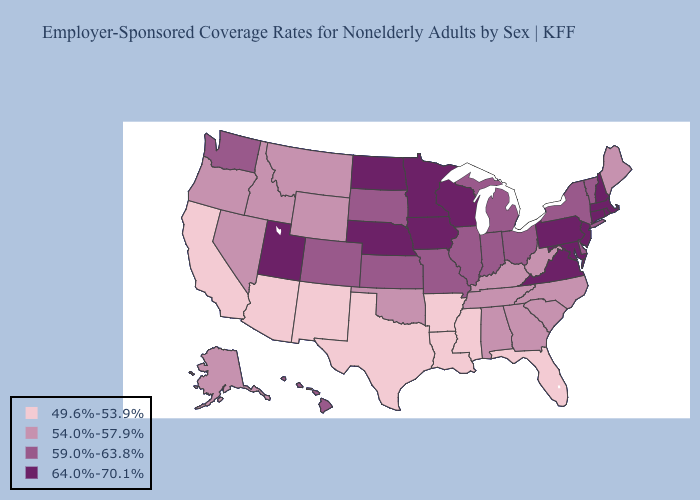What is the lowest value in states that border Minnesota?
Write a very short answer. 59.0%-63.8%. Among the states that border New Jersey , does New York have the highest value?
Write a very short answer. No. What is the value of Tennessee?
Answer briefly. 54.0%-57.9%. What is the lowest value in states that border Michigan?
Short answer required. 59.0%-63.8%. Name the states that have a value in the range 59.0%-63.8%?
Write a very short answer. Colorado, Delaware, Hawaii, Illinois, Indiana, Kansas, Michigan, Missouri, New York, Ohio, South Dakota, Vermont, Washington. Which states have the lowest value in the USA?
Write a very short answer. Arizona, Arkansas, California, Florida, Louisiana, Mississippi, New Mexico, Texas. Is the legend a continuous bar?
Be succinct. No. Name the states that have a value in the range 59.0%-63.8%?
Answer briefly. Colorado, Delaware, Hawaii, Illinois, Indiana, Kansas, Michigan, Missouri, New York, Ohio, South Dakota, Vermont, Washington. How many symbols are there in the legend?
Keep it brief. 4. What is the value of New York?
Give a very brief answer. 59.0%-63.8%. Does Connecticut have a higher value than Florida?
Give a very brief answer. Yes. Does Rhode Island have the highest value in the USA?
Keep it brief. Yes. What is the value of North Dakota?
Be succinct. 64.0%-70.1%. Name the states that have a value in the range 59.0%-63.8%?
Short answer required. Colorado, Delaware, Hawaii, Illinois, Indiana, Kansas, Michigan, Missouri, New York, Ohio, South Dakota, Vermont, Washington. Name the states that have a value in the range 64.0%-70.1%?
Short answer required. Connecticut, Iowa, Maryland, Massachusetts, Minnesota, Nebraska, New Hampshire, New Jersey, North Dakota, Pennsylvania, Rhode Island, Utah, Virginia, Wisconsin. 